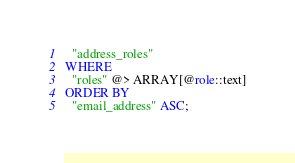<code> <loc_0><loc_0><loc_500><loc_500><_SQL_>  "address_roles"
WHERE
  "roles" @> ARRAY[@role::text]
ORDER BY
  "email_address" ASC;
</code> 